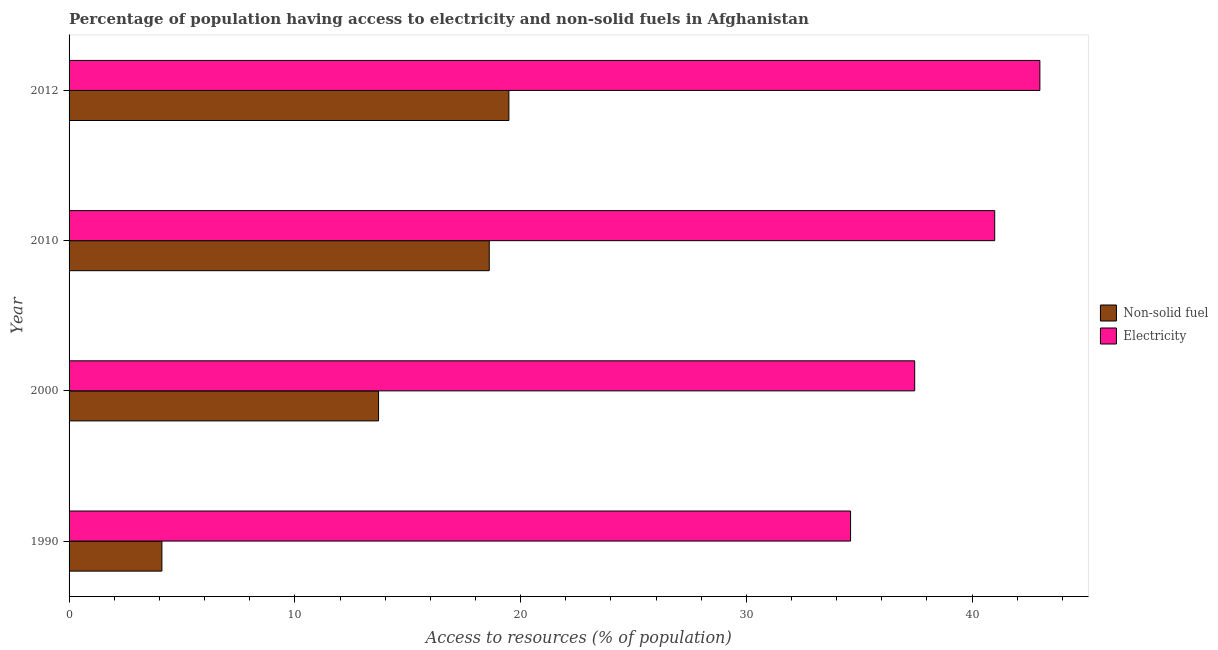How many groups of bars are there?
Offer a very short reply. 4. How many bars are there on the 3rd tick from the top?
Keep it short and to the point. 2. In how many cases, is the number of bars for a given year not equal to the number of legend labels?
Provide a short and direct response. 0. What is the percentage of population having access to electricity in 2012?
Give a very brief answer. 43. Across all years, what is the maximum percentage of population having access to electricity?
Your answer should be very brief. 43. Across all years, what is the minimum percentage of population having access to non-solid fuel?
Your answer should be very brief. 4.11. In which year was the percentage of population having access to electricity maximum?
Offer a very short reply. 2012. What is the total percentage of population having access to non-solid fuel in the graph?
Offer a very short reply. 55.91. What is the difference between the percentage of population having access to electricity in 2010 and that in 2012?
Provide a short and direct response. -2. What is the difference between the percentage of population having access to electricity in 2012 and the percentage of population having access to non-solid fuel in 2010?
Provide a succinct answer. 24.39. What is the average percentage of population having access to non-solid fuel per year?
Ensure brevity in your answer.  13.98. In the year 1990, what is the difference between the percentage of population having access to non-solid fuel and percentage of population having access to electricity?
Provide a short and direct response. -30.5. In how many years, is the percentage of population having access to electricity greater than 42 %?
Your answer should be very brief. 1. What is the ratio of the percentage of population having access to non-solid fuel in 1990 to that in 2000?
Offer a terse response. 0.3. What is the difference between the highest and the second highest percentage of population having access to electricity?
Your answer should be very brief. 2. What is the difference between the highest and the lowest percentage of population having access to electricity?
Offer a terse response. 8.38. What does the 1st bar from the top in 1990 represents?
Your response must be concise. Electricity. What does the 1st bar from the bottom in 2000 represents?
Ensure brevity in your answer.  Non-solid fuel. How many bars are there?
Keep it short and to the point. 8. What is the difference between two consecutive major ticks on the X-axis?
Your response must be concise. 10. Are the values on the major ticks of X-axis written in scientific E-notation?
Your answer should be very brief. No. Does the graph contain grids?
Your answer should be very brief. No. How many legend labels are there?
Keep it short and to the point. 2. How are the legend labels stacked?
Provide a succinct answer. Vertical. What is the title of the graph?
Your answer should be very brief. Percentage of population having access to electricity and non-solid fuels in Afghanistan. Does "Arms imports" appear as one of the legend labels in the graph?
Make the answer very short. No. What is the label or title of the X-axis?
Keep it short and to the point. Access to resources (% of population). What is the label or title of the Y-axis?
Provide a short and direct response. Year. What is the Access to resources (% of population) in Non-solid fuel in 1990?
Give a very brief answer. 4.11. What is the Access to resources (% of population) of Electricity in 1990?
Ensure brevity in your answer.  34.62. What is the Access to resources (% of population) of Non-solid fuel in 2000?
Provide a short and direct response. 13.71. What is the Access to resources (% of population) in Electricity in 2000?
Your answer should be compact. 37.46. What is the Access to resources (% of population) of Non-solid fuel in 2010?
Provide a succinct answer. 18.61. What is the Access to resources (% of population) of Non-solid fuel in 2012?
Ensure brevity in your answer.  19.48. Across all years, what is the maximum Access to resources (% of population) of Non-solid fuel?
Your response must be concise. 19.48. Across all years, what is the maximum Access to resources (% of population) in Electricity?
Your answer should be compact. 43. Across all years, what is the minimum Access to resources (% of population) in Non-solid fuel?
Give a very brief answer. 4.11. Across all years, what is the minimum Access to resources (% of population) of Electricity?
Keep it short and to the point. 34.62. What is the total Access to resources (% of population) of Non-solid fuel in the graph?
Ensure brevity in your answer.  55.91. What is the total Access to resources (% of population) of Electricity in the graph?
Offer a terse response. 156.07. What is the difference between the Access to resources (% of population) of Non-solid fuel in 1990 and that in 2000?
Your response must be concise. -9.6. What is the difference between the Access to resources (% of population) of Electricity in 1990 and that in 2000?
Your response must be concise. -2.84. What is the difference between the Access to resources (% of population) in Non-solid fuel in 1990 and that in 2010?
Your answer should be compact. -14.5. What is the difference between the Access to resources (% of population) of Electricity in 1990 and that in 2010?
Provide a succinct answer. -6.38. What is the difference between the Access to resources (% of population) in Non-solid fuel in 1990 and that in 2012?
Your response must be concise. -15.37. What is the difference between the Access to resources (% of population) in Electricity in 1990 and that in 2012?
Your answer should be very brief. -8.38. What is the difference between the Access to resources (% of population) of Non-solid fuel in 2000 and that in 2010?
Provide a short and direct response. -4.9. What is the difference between the Access to resources (% of population) in Electricity in 2000 and that in 2010?
Offer a terse response. -3.54. What is the difference between the Access to resources (% of population) of Non-solid fuel in 2000 and that in 2012?
Keep it short and to the point. -5.77. What is the difference between the Access to resources (% of population) in Electricity in 2000 and that in 2012?
Make the answer very short. -5.54. What is the difference between the Access to resources (% of population) of Non-solid fuel in 2010 and that in 2012?
Provide a short and direct response. -0.87. What is the difference between the Access to resources (% of population) in Electricity in 2010 and that in 2012?
Offer a terse response. -2. What is the difference between the Access to resources (% of population) in Non-solid fuel in 1990 and the Access to resources (% of population) in Electricity in 2000?
Ensure brevity in your answer.  -33.34. What is the difference between the Access to resources (% of population) of Non-solid fuel in 1990 and the Access to resources (% of population) of Electricity in 2010?
Ensure brevity in your answer.  -36.89. What is the difference between the Access to resources (% of population) of Non-solid fuel in 1990 and the Access to resources (% of population) of Electricity in 2012?
Your response must be concise. -38.89. What is the difference between the Access to resources (% of population) of Non-solid fuel in 2000 and the Access to resources (% of population) of Electricity in 2010?
Offer a terse response. -27.29. What is the difference between the Access to resources (% of population) of Non-solid fuel in 2000 and the Access to resources (% of population) of Electricity in 2012?
Keep it short and to the point. -29.29. What is the difference between the Access to resources (% of population) of Non-solid fuel in 2010 and the Access to resources (% of population) of Electricity in 2012?
Ensure brevity in your answer.  -24.39. What is the average Access to resources (% of population) in Non-solid fuel per year?
Offer a terse response. 13.98. What is the average Access to resources (% of population) in Electricity per year?
Your response must be concise. 39.02. In the year 1990, what is the difference between the Access to resources (% of population) of Non-solid fuel and Access to resources (% of population) of Electricity?
Offer a very short reply. -30.5. In the year 2000, what is the difference between the Access to resources (% of population) in Non-solid fuel and Access to resources (% of population) in Electricity?
Ensure brevity in your answer.  -23.75. In the year 2010, what is the difference between the Access to resources (% of population) of Non-solid fuel and Access to resources (% of population) of Electricity?
Your answer should be compact. -22.39. In the year 2012, what is the difference between the Access to resources (% of population) in Non-solid fuel and Access to resources (% of population) in Electricity?
Provide a succinct answer. -23.52. What is the ratio of the Access to resources (% of population) of Non-solid fuel in 1990 to that in 2000?
Keep it short and to the point. 0.3. What is the ratio of the Access to resources (% of population) of Electricity in 1990 to that in 2000?
Provide a short and direct response. 0.92. What is the ratio of the Access to resources (% of population) in Non-solid fuel in 1990 to that in 2010?
Your answer should be compact. 0.22. What is the ratio of the Access to resources (% of population) of Electricity in 1990 to that in 2010?
Offer a terse response. 0.84. What is the ratio of the Access to resources (% of population) in Non-solid fuel in 1990 to that in 2012?
Offer a terse response. 0.21. What is the ratio of the Access to resources (% of population) of Electricity in 1990 to that in 2012?
Keep it short and to the point. 0.81. What is the ratio of the Access to resources (% of population) of Non-solid fuel in 2000 to that in 2010?
Your response must be concise. 0.74. What is the ratio of the Access to resources (% of population) of Electricity in 2000 to that in 2010?
Your response must be concise. 0.91. What is the ratio of the Access to resources (% of population) in Non-solid fuel in 2000 to that in 2012?
Make the answer very short. 0.7. What is the ratio of the Access to resources (% of population) of Electricity in 2000 to that in 2012?
Offer a very short reply. 0.87. What is the ratio of the Access to resources (% of population) in Non-solid fuel in 2010 to that in 2012?
Offer a terse response. 0.96. What is the ratio of the Access to resources (% of population) in Electricity in 2010 to that in 2012?
Give a very brief answer. 0.95. What is the difference between the highest and the second highest Access to resources (% of population) in Non-solid fuel?
Your response must be concise. 0.87. What is the difference between the highest and the second highest Access to resources (% of population) of Electricity?
Provide a succinct answer. 2. What is the difference between the highest and the lowest Access to resources (% of population) of Non-solid fuel?
Keep it short and to the point. 15.37. What is the difference between the highest and the lowest Access to resources (% of population) in Electricity?
Provide a short and direct response. 8.38. 